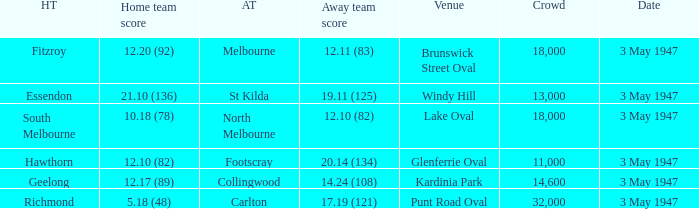In the game where the home team scored 12.17 (89), who was the home team? Geelong. Could you parse the entire table as a dict? {'header': ['HT', 'Home team score', 'AT', 'Away team score', 'Venue', 'Crowd', 'Date'], 'rows': [['Fitzroy', '12.20 (92)', 'Melbourne', '12.11 (83)', 'Brunswick Street Oval', '18,000', '3 May 1947'], ['Essendon', '21.10 (136)', 'St Kilda', '19.11 (125)', 'Windy Hill', '13,000', '3 May 1947'], ['South Melbourne', '10.18 (78)', 'North Melbourne', '12.10 (82)', 'Lake Oval', '18,000', '3 May 1947'], ['Hawthorn', '12.10 (82)', 'Footscray', '20.14 (134)', 'Glenferrie Oval', '11,000', '3 May 1947'], ['Geelong', '12.17 (89)', 'Collingwood', '14.24 (108)', 'Kardinia Park', '14,600', '3 May 1947'], ['Richmond', '5.18 (48)', 'Carlton', '17.19 (121)', 'Punt Road Oval', '32,000', '3 May 1947']]} 